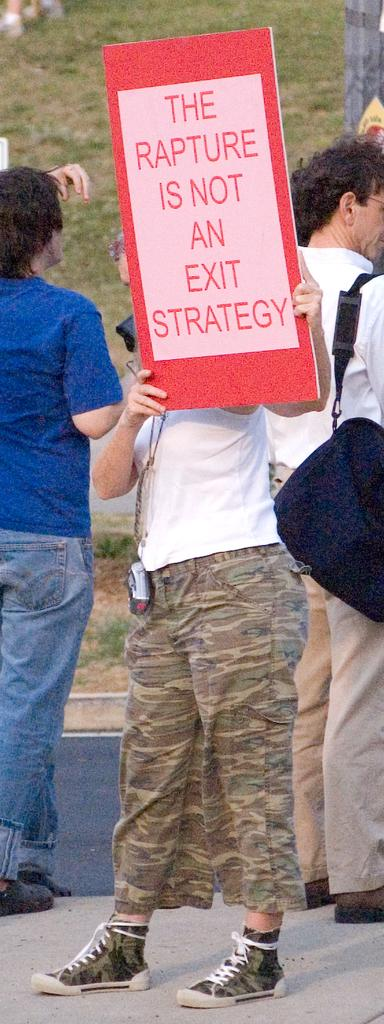How many people are in the image? There are three persons in the image. What are the persons doing in the image? The persons are standing on the ground. Can you describe what one of the persons is holding? One person is holding a board. What can be seen in the background of the image? There is grass in the background of the image. What type of yarn is the cook using to prepare the meal in the image? There is no cook or yarn present in the image. What is the father's role in the image? There is no father or indication of familial relationships in the image. 